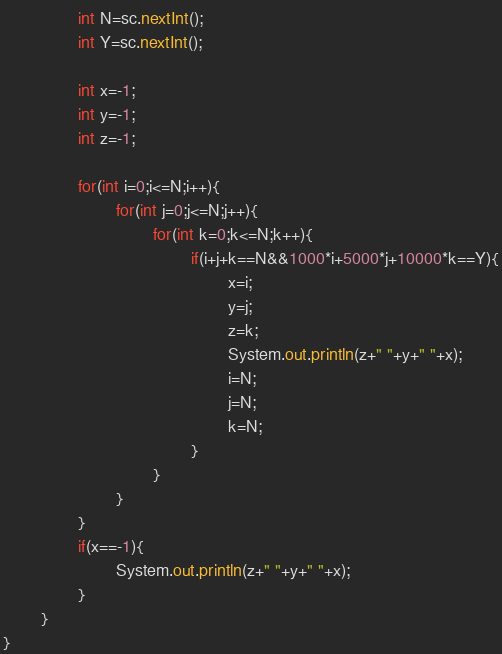<code> <loc_0><loc_0><loc_500><loc_500><_Java_>                int N=sc.nextInt();
                int Y=sc.nextInt();

                int x=-1;
                int y=-1;
                int z=-1;

                for(int i=0;i<=N;i++){
                        for(int j=0;j<=N;j++){
                                for(int k=0;k<=N;k++){
                                        if(i+j+k==N&&1000*i+5000*j+10000*k==Y){
                                                x=i;
                                                y=j;
                                                z=k;
                                                System.out.println(z+" "+y+" "+x);
                                                i=N;
                                                j=N;
                                                k=N;
                                        }
                                }
                        }
                }
                if(x==-1){
                        System.out.println(z+" "+y+" "+x);
                }
        }
}</code> 